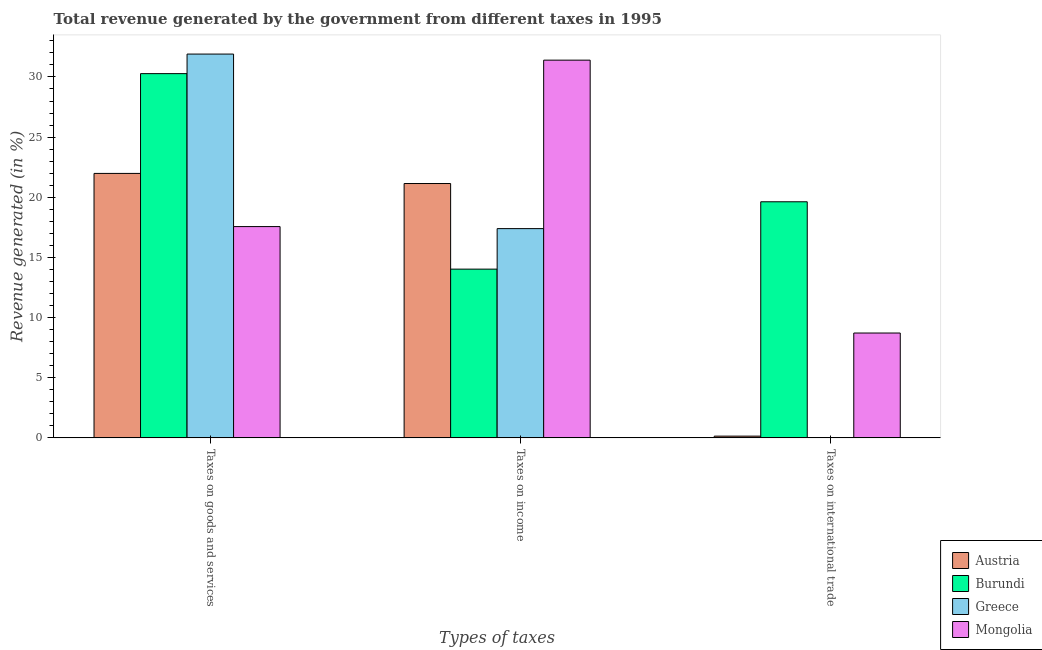How many different coloured bars are there?
Give a very brief answer. 4. Are the number of bars on each tick of the X-axis equal?
Your answer should be compact. No. How many bars are there on the 1st tick from the left?
Your answer should be very brief. 4. What is the label of the 3rd group of bars from the left?
Keep it short and to the point. Taxes on international trade. What is the percentage of revenue generated by taxes on income in Austria?
Keep it short and to the point. 21.14. Across all countries, what is the maximum percentage of revenue generated by tax on international trade?
Offer a very short reply. 19.62. Across all countries, what is the minimum percentage of revenue generated by taxes on income?
Give a very brief answer. 14.03. In which country was the percentage of revenue generated by taxes on income maximum?
Make the answer very short. Mongolia. What is the total percentage of revenue generated by taxes on income in the graph?
Provide a short and direct response. 83.96. What is the difference between the percentage of revenue generated by taxes on income in Mongolia and that in Greece?
Provide a succinct answer. 14. What is the difference between the percentage of revenue generated by tax on international trade in Burundi and the percentage of revenue generated by taxes on goods and services in Mongolia?
Offer a terse response. 2.06. What is the average percentage of revenue generated by taxes on goods and services per country?
Keep it short and to the point. 25.43. What is the difference between the percentage of revenue generated by taxes on goods and services and percentage of revenue generated by taxes on income in Mongolia?
Your response must be concise. -13.83. What is the ratio of the percentage of revenue generated by taxes on income in Mongolia to that in Austria?
Keep it short and to the point. 1.49. What is the difference between the highest and the second highest percentage of revenue generated by taxes on income?
Provide a short and direct response. 10.26. What is the difference between the highest and the lowest percentage of revenue generated by taxes on income?
Your answer should be compact. 17.37. In how many countries, is the percentage of revenue generated by taxes on goods and services greater than the average percentage of revenue generated by taxes on goods and services taken over all countries?
Provide a succinct answer. 2. Are all the bars in the graph horizontal?
Ensure brevity in your answer.  No. Are the values on the major ticks of Y-axis written in scientific E-notation?
Your response must be concise. No. How many legend labels are there?
Ensure brevity in your answer.  4. How are the legend labels stacked?
Provide a succinct answer. Vertical. What is the title of the graph?
Keep it short and to the point. Total revenue generated by the government from different taxes in 1995. What is the label or title of the X-axis?
Offer a very short reply. Types of taxes. What is the label or title of the Y-axis?
Your answer should be very brief. Revenue generated (in %). What is the Revenue generated (in %) of Austria in Taxes on goods and services?
Provide a succinct answer. 21.98. What is the Revenue generated (in %) in Burundi in Taxes on goods and services?
Your answer should be compact. 30.28. What is the Revenue generated (in %) of Greece in Taxes on goods and services?
Offer a terse response. 31.9. What is the Revenue generated (in %) in Mongolia in Taxes on goods and services?
Offer a very short reply. 17.56. What is the Revenue generated (in %) of Austria in Taxes on income?
Offer a terse response. 21.14. What is the Revenue generated (in %) of Burundi in Taxes on income?
Make the answer very short. 14.03. What is the Revenue generated (in %) in Greece in Taxes on income?
Provide a succinct answer. 17.39. What is the Revenue generated (in %) in Mongolia in Taxes on income?
Give a very brief answer. 31.4. What is the Revenue generated (in %) of Austria in Taxes on international trade?
Keep it short and to the point. 0.14. What is the Revenue generated (in %) in Burundi in Taxes on international trade?
Your response must be concise. 19.62. What is the Revenue generated (in %) of Mongolia in Taxes on international trade?
Make the answer very short. 8.72. Across all Types of taxes, what is the maximum Revenue generated (in %) in Austria?
Provide a succinct answer. 21.98. Across all Types of taxes, what is the maximum Revenue generated (in %) in Burundi?
Offer a terse response. 30.28. Across all Types of taxes, what is the maximum Revenue generated (in %) in Greece?
Your response must be concise. 31.9. Across all Types of taxes, what is the maximum Revenue generated (in %) of Mongolia?
Ensure brevity in your answer.  31.4. Across all Types of taxes, what is the minimum Revenue generated (in %) of Austria?
Keep it short and to the point. 0.14. Across all Types of taxes, what is the minimum Revenue generated (in %) in Burundi?
Your answer should be very brief. 14.03. Across all Types of taxes, what is the minimum Revenue generated (in %) of Mongolia?
Offer a very short reply. 8.72. What is the total Revenue generated (in %) in Austria in the graph?
Give a very brief answer. 43.27. What is the total Revenue generated (in %) in Burundi in the graph?
Your answer should be very brief. 63.93. What is the total Revenue generated (in %) in Greece in the graph?
Offer a very short reply. 49.3. What is the total Revenue generated (in %) in Mongolia in the graph?
Offer a very short reply. 57.67. What is the difference between the Revenue generated (in %) in Austria in Taxes on goods and services and that in Taxes on income?
Give a very brief answer. 0.84. What is the difference between the Revenue generated (in %) in Burundi in Taxes on goods and services and that in Taxes on income?
Give a very brief answer. 16.25. What is the difference between the Revenue generated (in %) of Greece in Taxes on goods and services and that in Taxes on income?
Ensure brevity in your answer.  14.51. What is the difference between the Revenue generated (in %) in Mongolia in Taxes on goods and services and that in Taxes on income?
Ensure brevity in your answer.  -13.83. What is the difference between the Revenue generated (in %) of Austria in Taxes on goods and services and that in Taxes on international trade?
Your answer should be very brief. 21.84. What is the difference between the Revenue generated (in %) in Burundi in Taxes on goods and services and that in Taxes on international trade?
Offer a terse response. 10.65. What is the difference between the Revenue generated (in %) of Mongolia in Taxes on goods and services and that in Taxes on international trade?
Make the answer very short. 8.85. What is the difference between the Revenue generated (in %) of Austria in Taxes on income and that in Taxes on international trade?
Your answer should be very brief. 21. What is the difference between the Revenue generated (in %) of Burundi in Taxes on income and that in Taxes on international trade?
Make the answer very short. -5.6. What is the difference between the Revenue generated (in %) of Mongolia in Taxes on income and that in Taxes on international trade?
Provide a succinct answer. 22.68. What is the difference between the Revenue generated (in %) of Austria in Taxes on goods and services and the Revenue generated (in %) of Burundi in Taxes on income?
Offer a very short reply. 7.96. What is the difference between the Revenue generated (in %) of Austria in Taxes on goods and services and the Revenue generated (in %) of Greece in Taxes on income?
Offer a very short reply. 4.59. What is the difference between the Revenue generated (in %) in Austria in Taxes on goods and services and the Revenue generated (in %) in Mongolia in Taxes on income?
Your response must be concise. -9.42. What is the difference between the Revenue generated (in %) of Burundi in Taxes on goods and services and the Revenue generated (in %) of Greece in Taxes on income?
Provide a succinct answer. 12.88. What is the difference between the Revenue generated (in %) in Burundi in Taxes on goods and services and the Revenue generated (in %) in Mongolia in Taxes on income?
Make the answer very short. -1.12. What is the difference between the Revenue generated (in %) of Greece in Taxes on goods and services and the Revenue generated (in %) of Mongolia in Taxes on income?
Offer a terse response. 0.51. What is the difference between the Revenue generated (in %) of Austria in Taxes on goods and services and the Revenue generated (in %) of Burundi in Taxes on international trade?
Ensure brevity in your answer.  2.36. What is the difference between the Revenue generated (in %) in Austria in Taxes on goods and services and the Revenue generated (in %) in Mongolia in Taxes on international trade?
Give a very brief answer. 13.27. What is the difference between the Revenue generated (in %) in Burundi in Taxes on goods and services and the Revenue generated (in %) in Mongolia in Taxes on international trade?
Provide a short and direct response. 21.56. What is the difference between the Revenue generated (in %) in Greece in Taxes on goods and services and the Revenue generated (in %) in Mongolia in Taxes on international trade?
Provide a succinct answer. 23.19. What is the difference between the Revenue generated (in %) of Austria in Taxes on income and the Revenue generated (in %) of Burundi in Taxes on international trade?
Give a very brief answer. 1.52. What is the difference between the Revenue generated (in %) in Austria in Taxes on income and the Revenue generated (in %) in Mongolia in Taxes on international trade?
Keep it short and to the point. 12.43. What is the difference between the Revenue generated (in %) in Burundi in Taxes on income and the Revenue generated (in %) in Mongolia in Taxes on international trade?
Offer a very short reply. 5.31. What is the difference between the Revenue generated (in %) of Greece in Taxes on income and the Revenue generated (in %) of Mongolia in Taxes on international trade?
Make the answer very short. 8.68. What is the average Revenue generated (in %) of Austria per Types of taxes?
Keep it short and to the point. 14.42. What is the average Revenue generated (in %) of Burundi per Types of taxes?
Provide a succinct answer. 21.31. What is the average Revenue generated (in %) in Greece per Types of taxes?
Give a very brief answer. 16.43. What is the average Revenue generated (in %) of Mongolia per Types of taxes?
Offer a very short reply. 19.22. What is the difference between the Revenue generated (in %) in Austria and Revenue generated (in %) in Burundi in Taxes on goods and services?
Offer a very short reply. -8.29. What is the difference between the Revenue generated (in %) of Austria and Revenue generated (in %) of Greece in Taxes on goods and services?
Give a very brief answer. -9.92. What is the difference between the Revenue generated (in %) of Austria and Revenue generated (in %) of Mongolia in Taxes on goods and services?
Ensure brevity in your answer.  4.42. What is the difference between the Revenue generated (in %) in Burundi and Revenue generated (in %) in Greece in Taxes on goods and services?
Make the answer very short. -1.63. What is the difference between the Revenue generated (in %) in Burundi and Revenue generated (in %) in Mongolia in Taxes on goods and services?
Give a very brief answer. 12.71. What is the difference between the Revenue generated (in %) of Greece and Revenue generated (in %) of Mongolia in Taxes on goods and services?
Give a very brief answer. 14.34. What is the difference between the Revenue generated (in %) of Austria and Revenue generated (in %) of Burundi in Taxes on income?
Your answer should be very brief. 7.12. What is the difference between the Revenue generated (in %) of Austria and Revenue generated (in %) of Greece in Taxes on income?
Ensure brevity in your answer.  3.75. What is the difference between the Revenue generated (in %) of Austria and Revenue generated (in %) of Mongolia in Taxes on income?
Offer a terse response. -10.26. What is the difference between the Revenue generated (in %) of Burundi and Revenue generated (in %) of Greece in Taxes on income?
Offer a very short reply. -3.37. What is the difference between the Revenue generated (in %) in Burundi and Revenue generated (in %) in Mongolia in Taxes on income?
Offer a very short reply. -17.37. What is the difference between the Revenue generated (in %) of Greece and Revenue generated (in %) of Mongolia in Taxes on income?
Ensure brevity in your answer.  -14. What is the difference between the Revenue generated (in %) in Austria and Revenue generated (in %) in Burundi in Taxes on international trade?
Ensure brevity in your answer.  -19.48. What is the difference between the Revenue generated (in %) in Austria and Revenue generated (in %) in Mongolia in Taxes on international trade?
Make the answer very short. -8.57. What is the difference between the Revenue generated (in %) of Burundi and Revenue generated (in %) of Mongolia in Taxes on international trade?
Make the answer very short. 10.91. What is the ratio of the Revenue generated (in %) in Austria in Taxes on goods and services to that in Taxes on income?
Make the answer very short. 1.04. What is the ratio of the Revenue generated (in %) of Burundi in Taxes on goods and services to that in Taxes on income?
Offer a very short reply. 2.16. What is the ratio of the Revenue generated (in %) of Greece in Taxes on goods and services to that in Taxes on income?
Provide a short and direct response. 1.83. What is the ratio of the Revenue generated (in %) of Mongolia in Taxes on goods and services to that in Taxes on income?
Your answer should be very brief. 0.56. What is the ratio of the Revenue generated (in %) of Austria in Taxes on goods and services to that in Taxes on international trade?
Make the answer very short. 152.31. What is the ratio of the Revenue generated (in %) in Burundi in Taxes on goods and services to that in Taxes on international trade?
Offer a very short reply. 1.54. What is the ratio of the Revenue generated (in %) in Mongolia in Taxes on goods and services to that in Taxes on international trade?
Your answer should be compact. 2.02. What is the ratio of the Revenue generated (in %) of Austria in Taxes on income to that in Taxes on international trade?
Make the answer very short. 146.49. What is the ratio of the Revenue generated (in %) in Burundi in Taxes on income to that in Taxes on international trade?
Provide a succinct answer. 0.71. What is the ratio of the Revenue generated (in %) of Mongolia in Taxes on income to that in Taxes on international trade?
Make the answer very short. 3.6. What is the difference between the highest and the second highest Revenue generated (in %) in Austria?
Make the answer very short. 0.84. What is the difference between the highest and the second highest Revenue generated (in %) of Burundi?
Make the answer very short. 10.65. What is the difference between the highest and the second highest Revenue generated (in %) in Mongolia?
Your response must be concise. 13.83. What is the difference between the highest and the lowest Revenue generated (in %) in Austria?
Your answer should be compact. 21.84. What is the difference between the highest and the lowest Revenue generated (in %) of Burundi?
Provide a short and direct response. 16.25. What is the difference between the highest and the lowest Revenue generated (in %) of Greece?
Make the answer very short. 31.9. What is the difference between the highest and the lowest Revenue generated (in %) in Mongolia?
Provide a succinct answer. 22.68. 